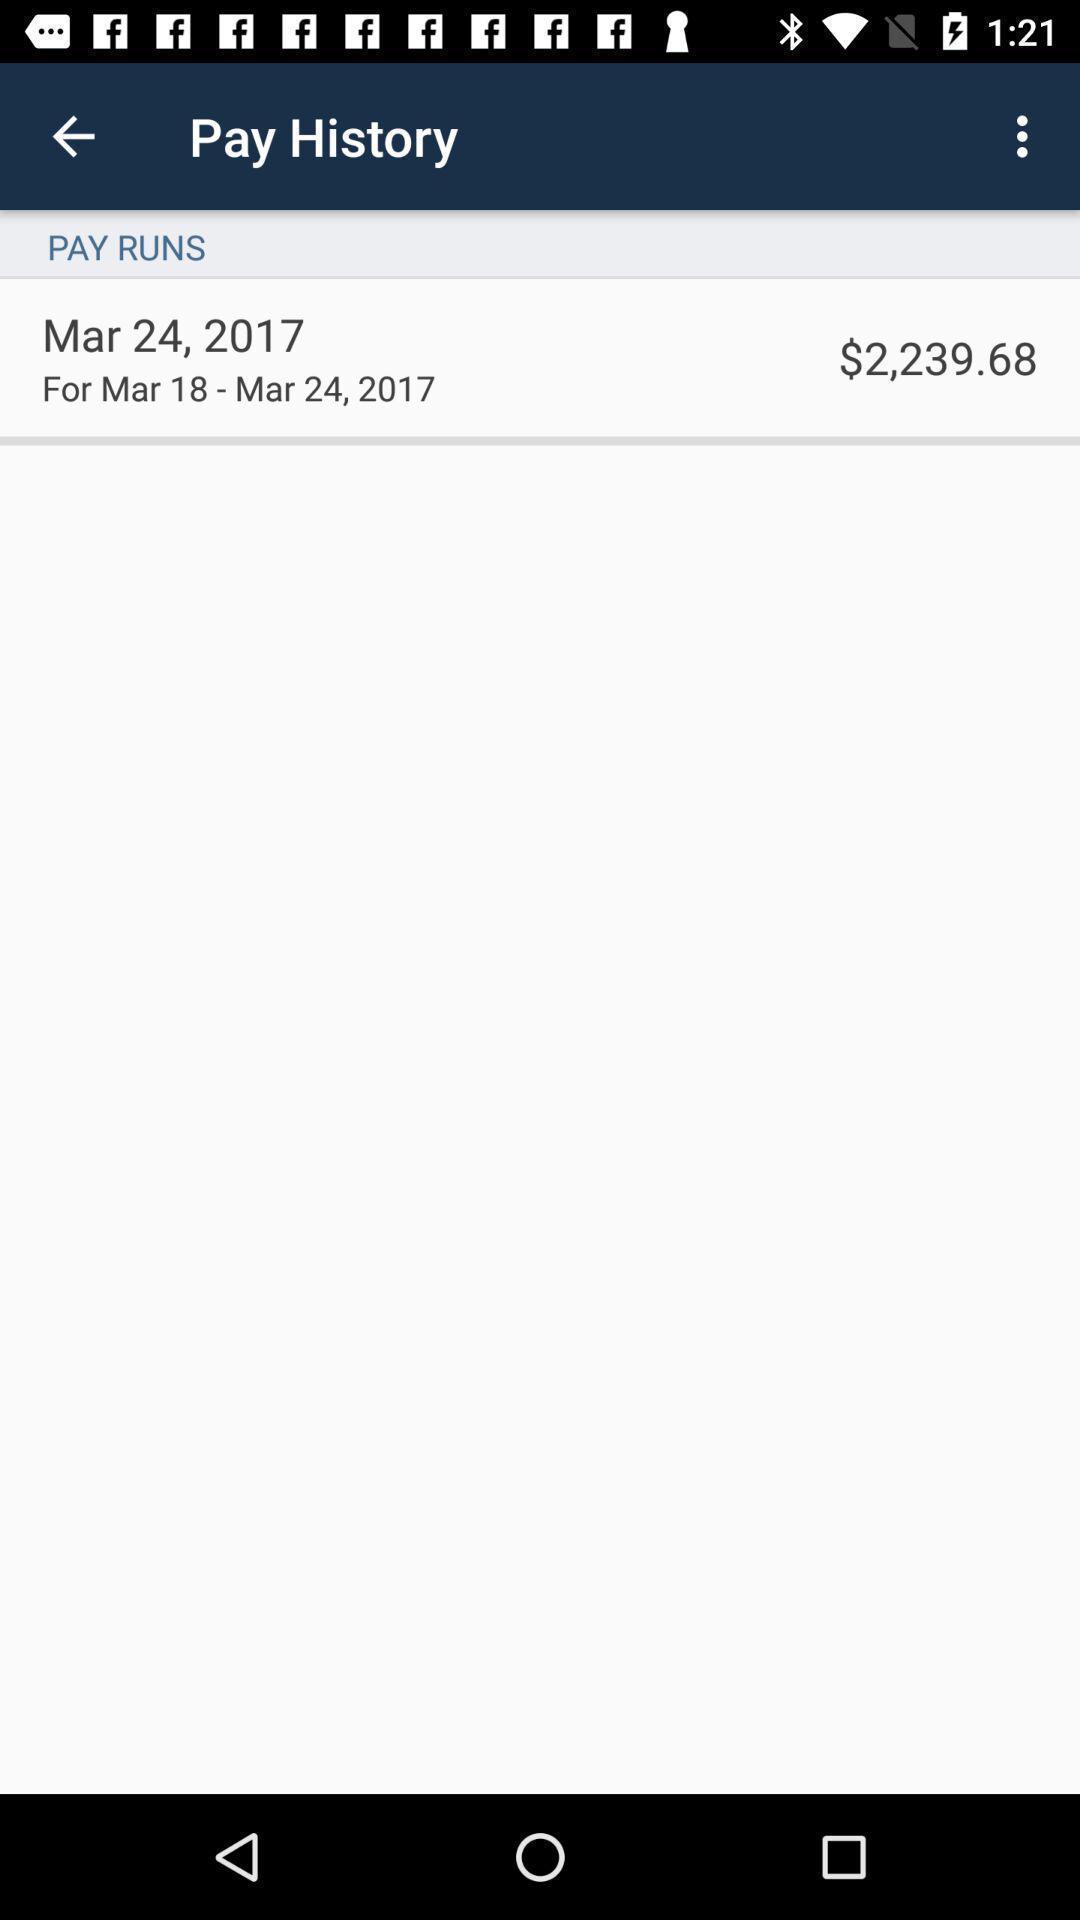Give me a summary of this screen capture. Screen showing pay history page of a financial app. 